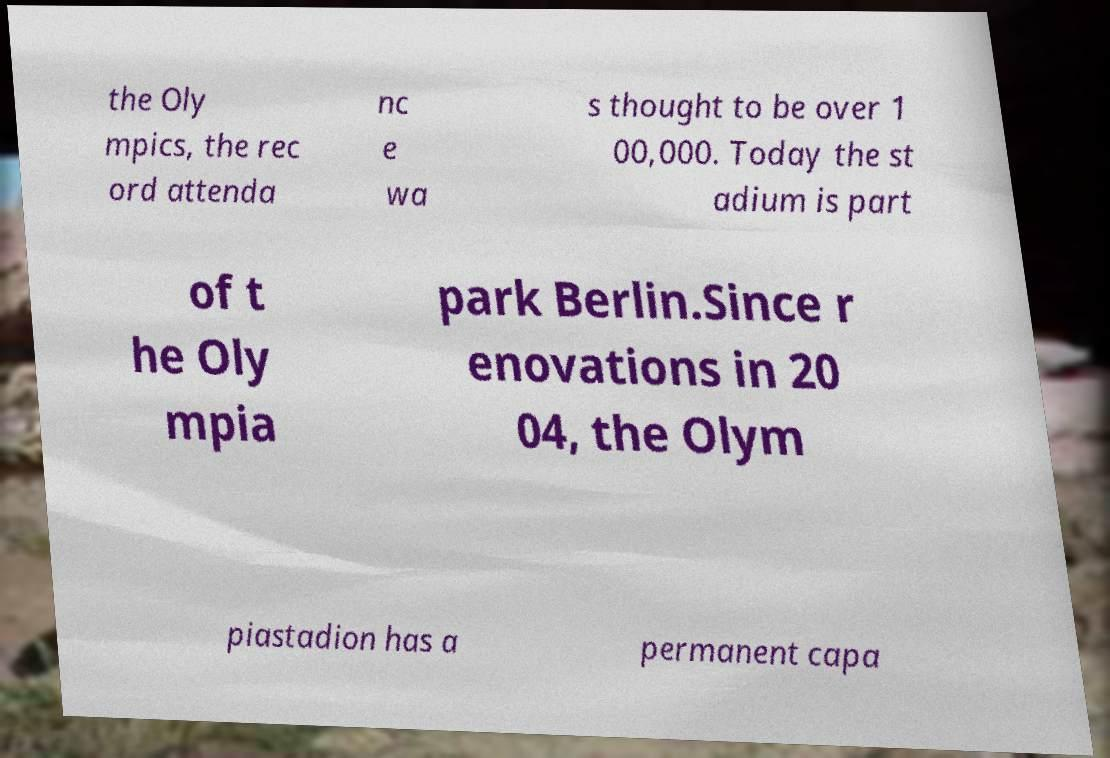I need the written content from this picture converted into text. Can you do that? the Oly mpics, the rec ord attenda nc e wa s thought to be over 1 00,000. Today the st adium is part of t he Oly mpia park Berlin.Since r enovations in 20 04, the Olym piastadion has a permanent capa 